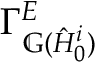<formula> <loc_0><loc_0><loc_500><loc_500>\Gamma _ { \mathbb { G } ( \hat { H } _ { 0 } ^ { i } ) } ^ { E }</formula> 